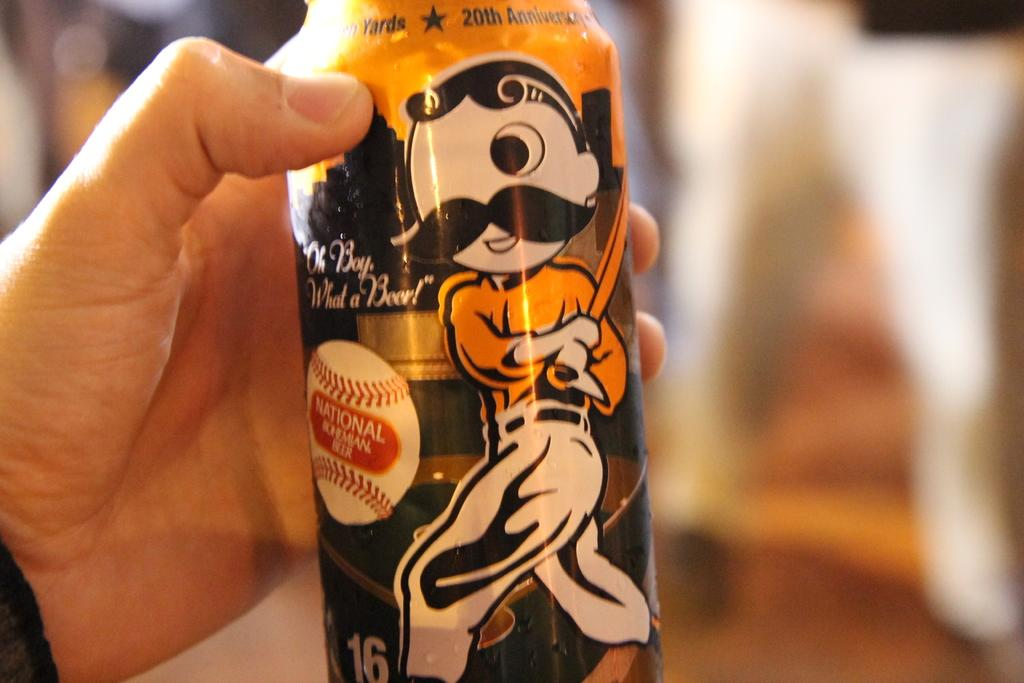<image>
Provide a brief description of the given image. A hand is holding a can with National and a drawing on it. 